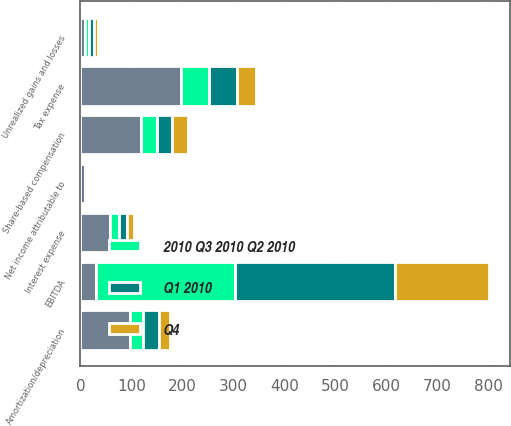Convert chart. <chart><loc_0><loc_0><loc_500><loc_500><stacked_bar_chart><ecel><fcel>Net income attributable to<fcel>Tax expense<fcel>Amortization/depreciation<fcel>Interest expense<fcel>Share-based compensation<fcel>Unrealized gains and losses<fcel>EBITDA<nl><fcel>nan<fcel>9.8<fcel>197<fcel>96.7<fcel>58.6<fcel>117.8<fcel>8.9<fcel>31.3<nl><fcel>Q1 2010<fcel>4.2<fcel>55.7<fcel>31.3<fcel>16<fcel>30.8<fcel>8.4<fcel>313.2<nl><fcel>2010 Q3 2010 Q2 2010<fcel>1.8<fcel>54.5<fcel>26.3<fcel>16.1<fcel>31.5<fcel>8.8<fcel>272.5<nl><fcel>Q4<fcel>2.2<fcel>36.7<fcel>20.8<fcel>14.1<fcel>31.3<fcel>7.7<fcel>184.9<nl></chart> 